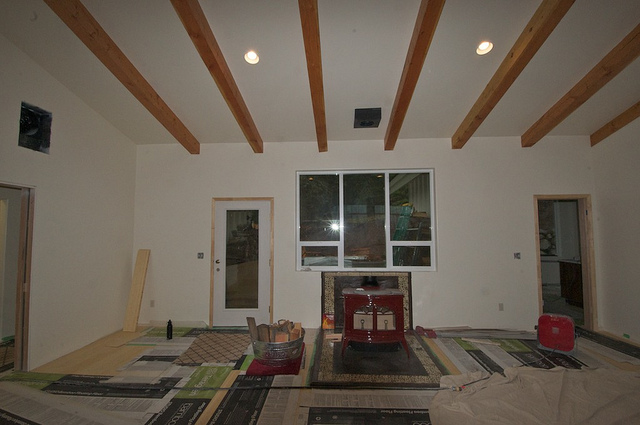<image>What color is the garbage can? There is no garbage can in the image. However, the color could be possibly silver, tan bucket or red. What color is the garbage can? There is no garbage can in the image. 